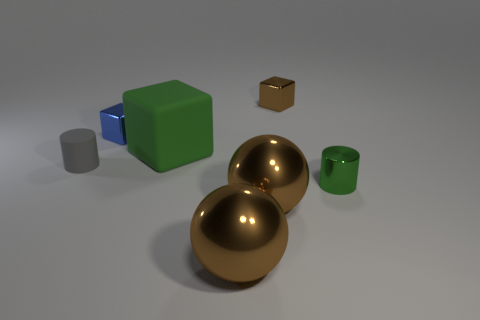Do the brown shiny cube and the green object behind the small green thing have the same size?
Make the answer very short. No. There is a matte object that is the same shape as the green metal thing; what color is it?
Make the answer very short. Gray. Does the blue thing to the left of the tiny brown object have the same size as the brown metal object that is behind the gray matte thing?
Provide a short and direct response. Yes. Is the shape of the gray thing the same as the small green shiny thing?
Provide a short and direct response. Yes. What number of things are shiny objects that are right of the tiny blue cube or big red balls?
Ensure brevity in your answer.  4. Is there a green thing of the same shape as the tiny blue metallic thing?
Your response must be concise. Yes. Is the number of big blocks that are on the right side of the big matte cube the same as the number of blue matte cylinders?
Offer a terse response. Yes. What is the shape of the thing that is the same color as the shiny cylinder?
Offer a terse response. Cube. How many rubber cylinders have the same size as the green metallic object?
Your answer should be compact. 1. What number of tiny blue shiny objects are in front of the tiny brown metal thing?
Offer a very short reply. 1. 